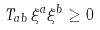Convert formula to latex. <formula><loc_0><loc_0><loc_500><loc_500>T _ { a b } \, \xi ^ { a } \xi ^ { b } \geq 0 \,</formula> 